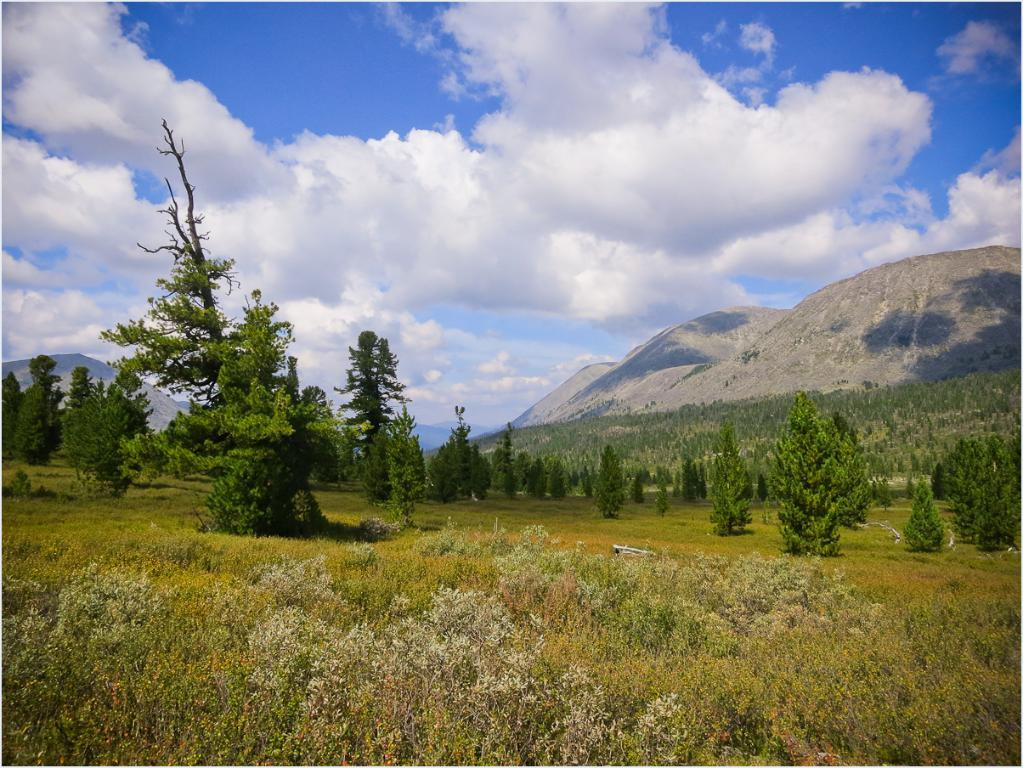What type of vegetation can be seen in the image? There is grass, plants, and trees in the image. What type of landscape feature is present in the image? There are hills in the image. What is visible at the top of the image? The sky is visible at the top of the image. What is the opinion of the country on the net in the image? There is no country or net present in the image, so it is not possible to determine any opinions. 